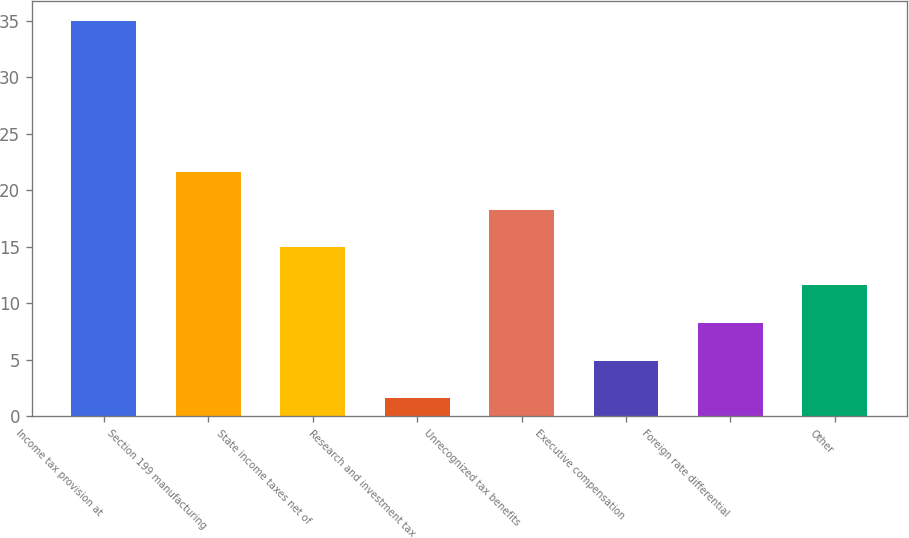Convert chart to OTSL. <chart><loc_0><loc_0><loc_500><loc_500><bar_chart><fcel>Income tax provision at<fcel>Section 199 manufacturing<fcel>State income taxes net of<fcel>Research and investment tax<fcel>Unrecognized tax benefits<fcel>Executive compensation<fcel>Foreign rate differential<fcel>Other<nl><fcel>35<fcel>21.64<fcel>14.96<fcel>1.6<fcel>18.3<fcel>4.94<fcel>8.28<fcel>11.62<nl></chart> 